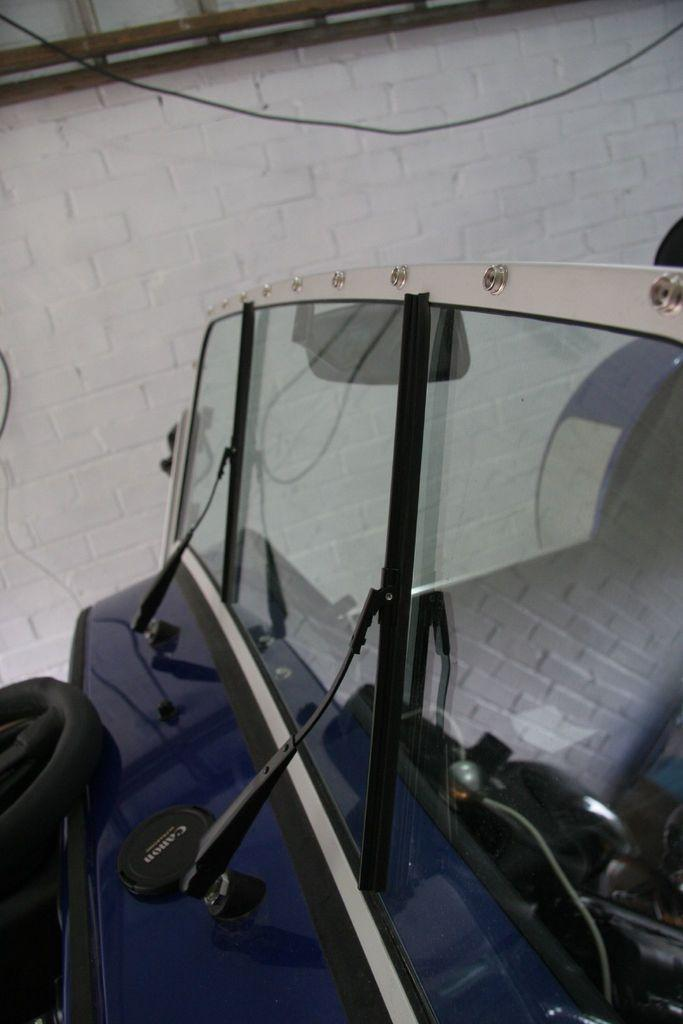What color is the vehicle in the image? The vehicle in the image is blue. Where is the vehicle located? The vehicle appears to be kept in a shed. What can be seen in the background of the image? There is a white wall and rods visible in the background of the image. Can you tell me how many goats are standing next to the vehicle in the image? There are no goats present in the image; it only features a blue vehicle in a shed with a white wall and rods in the background. 